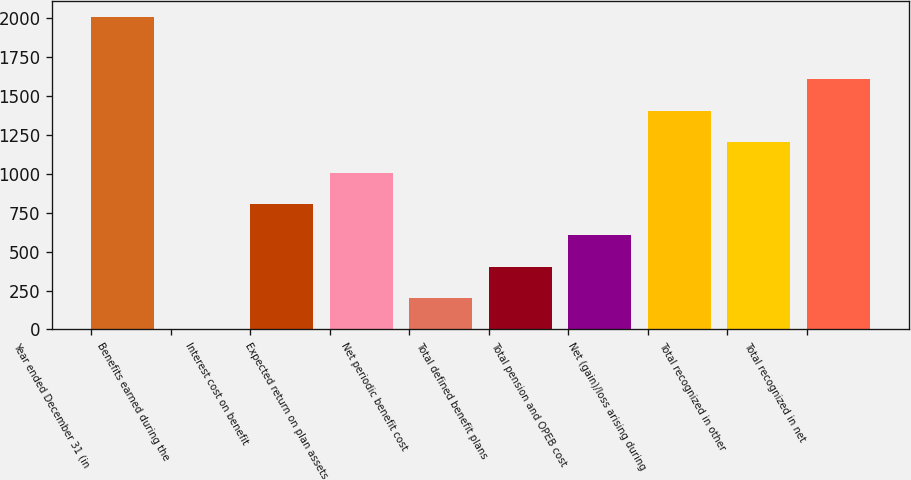Convert chart. <chart><loc_0><loc_0><loc_500><loc_500><bar_chart><fcel>Year ended December 31 (in<fcel>Benefits earned during the<fcel>Interest cost on benefit<fcel>Expected return on plan assets<fcel>Net periodic benefit cost<fcel>Total defined benefit plans<fcel>Total pension and OPEB cost<fcel>Net (gain)/loss arising during<fcel>Total recognized in other<fcel>Total recognized in net<nl><fcel>2009<fcel>3<fcel>805.4<fcel>1006<fcel>203.6<fcel>404.2<fcel>604.8<fcel>1407.2<fcel>1206.6<fcel>1607.8<nl></chart> 